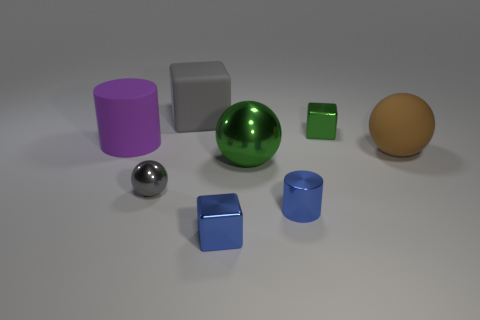What material is the tiny block behind the green metallic thing in front of the cylinder to the left of the gray ball? The tiny block behind the green metallic sphere and in front of the cylinder to the left of the gray ball appears to have a surface texture and reflections that suggest it could be made of a type of plastic or painted wood. Without tactile feedback or more detailed visual cues, it can be difficult to determine the exact material with certainty from a photograph alone. 